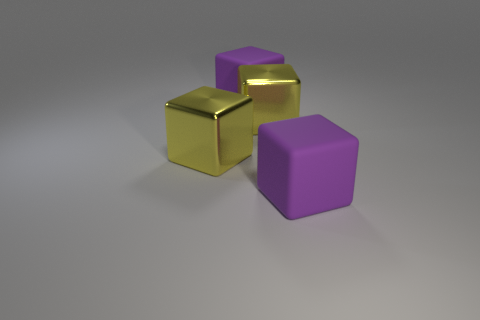What number of metallic things are either yellow blocks or large blocks?
Keep it short and to the point. 2. Are there fewer things than purple rubber blocks?
Ensure brevity in your answer.  No. What number of yellow things are there?
Provide a succinct answer. 2. What number of red things are either big cubes or large metallic things?
Provide a short and direct response. 0. How many cylinders are yellow metallic objects or big purple things?
Keep it short and to the point. 0. Is the number of large yellow metallic objects greater than the number of big blocks?
Your response must be concise. No. How many objects are either large purple blocks or shiny objects?
Keep it short and to the point. 4. Are there any large yellow things?
Ensure brevity in your answer.  Yes. How many big objects are either yellow shiny cubes or purple cubes?
Offer a very short reply. 4. 